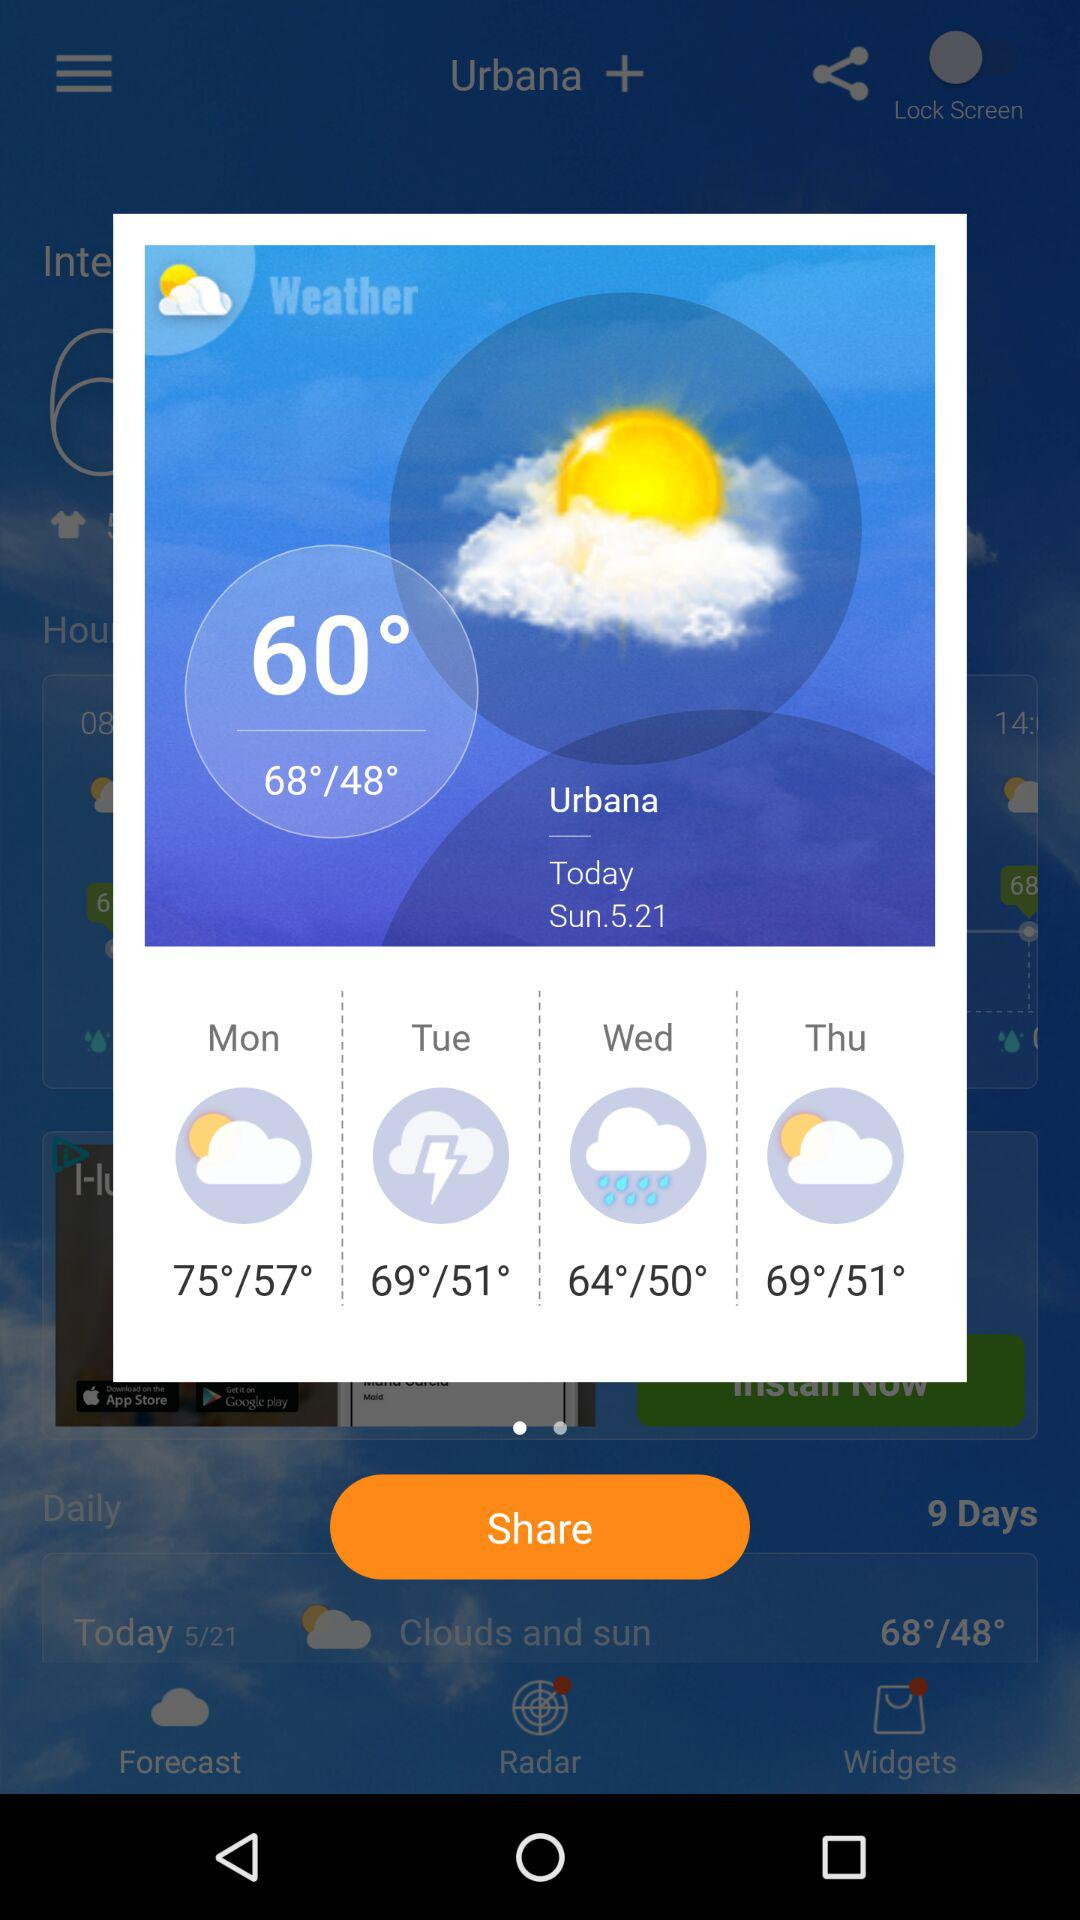What is the highest temperature on Thursday? The highest temperature on Thursday is 69°. 